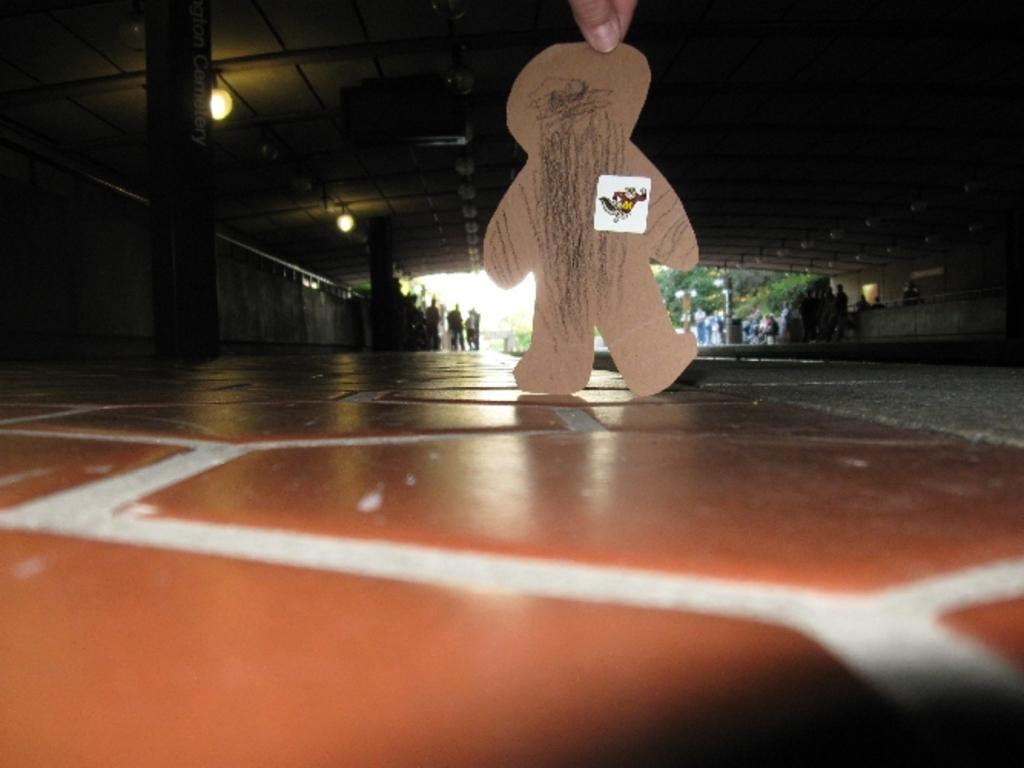What is the person holding in the image? The person is holding a cardboard piece in the shape of a person. What can be seen in the background of the image? There are lights, a group of people, and trees in the background of the image. What type of breakfast is being served to the person holding the cardboard piece in the image? There is no breakfast present in the image; the person is holding a cardboard piece in the shape of a person. 